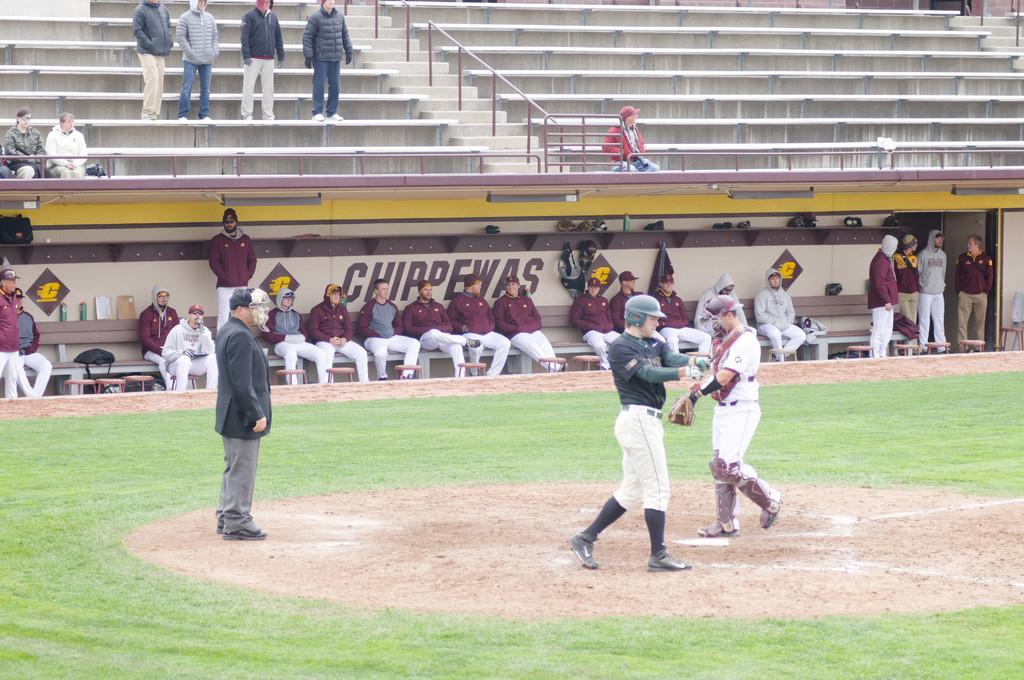<image>
Create a compact narrative representing the image presented. a player getting ready to bat while the Chippewas sit in the dugout 